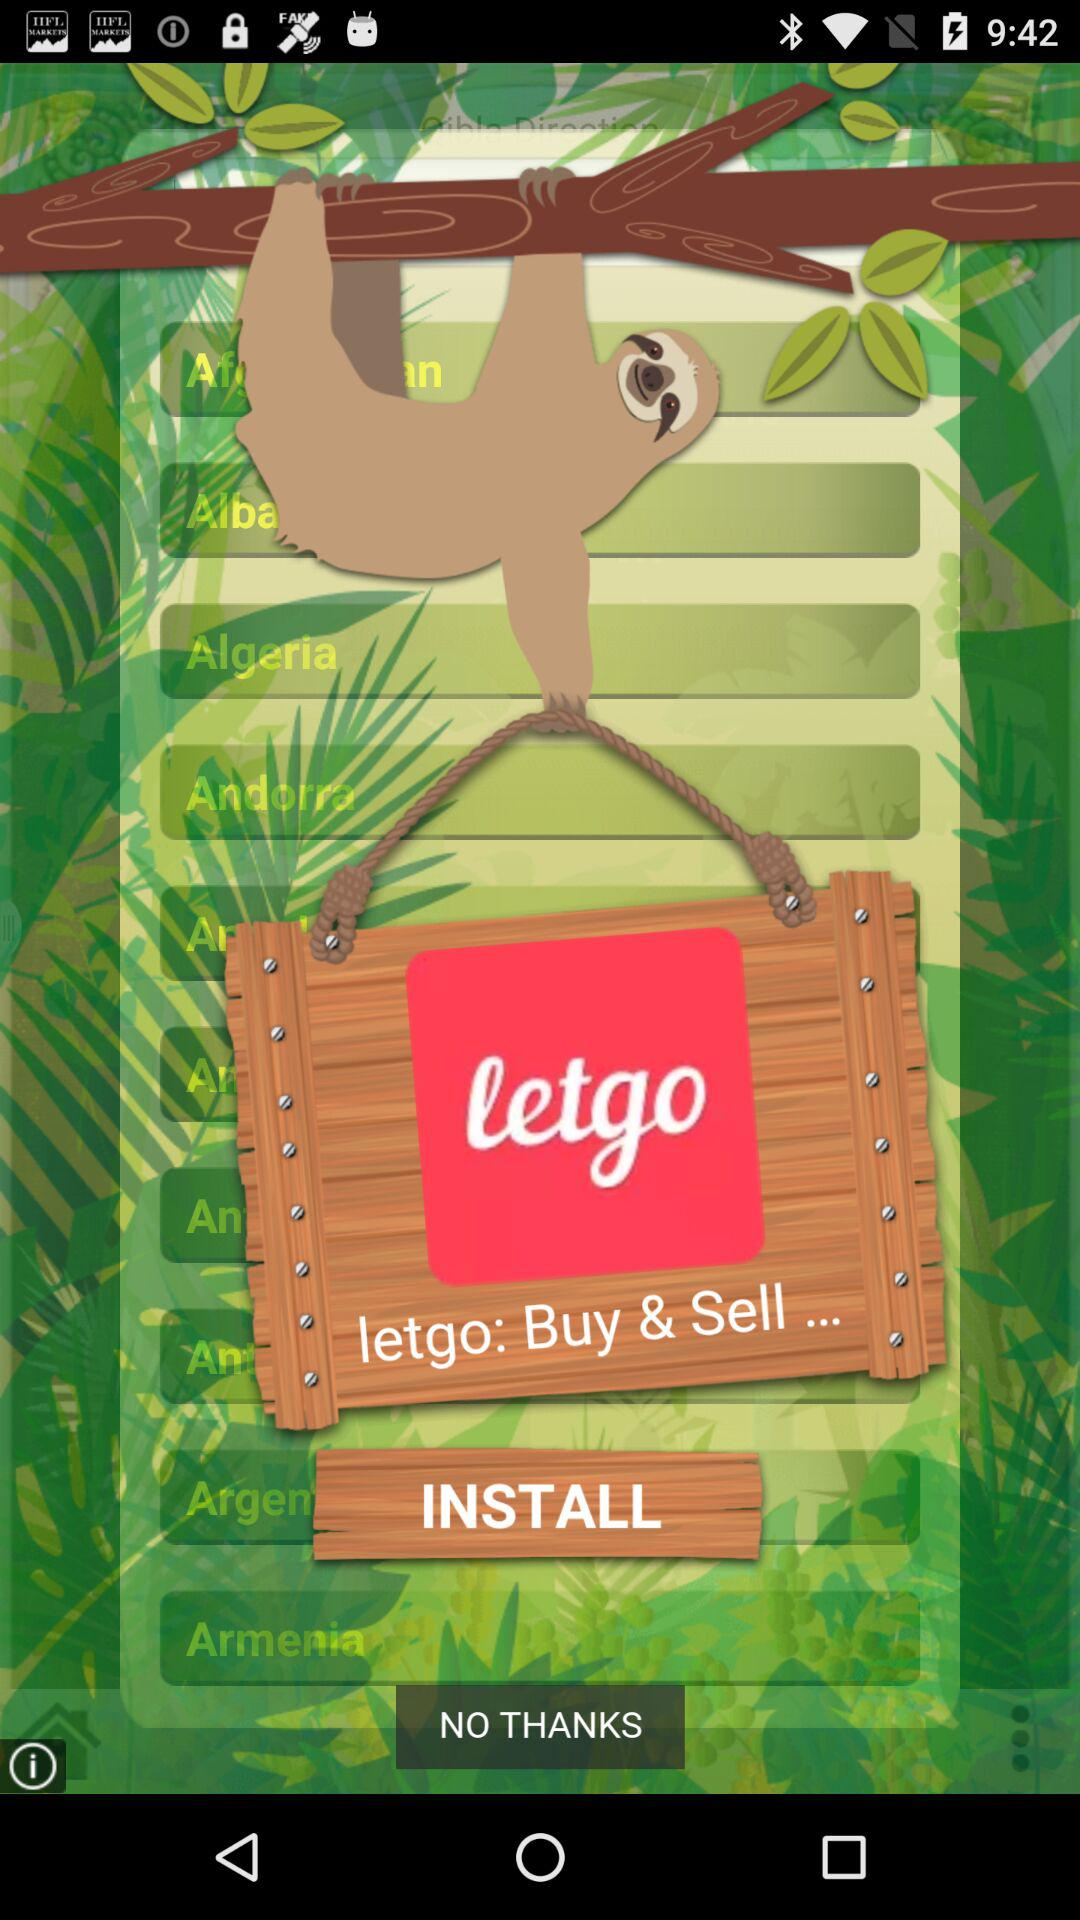What is the name of the application? The name of the application is "letgo". 